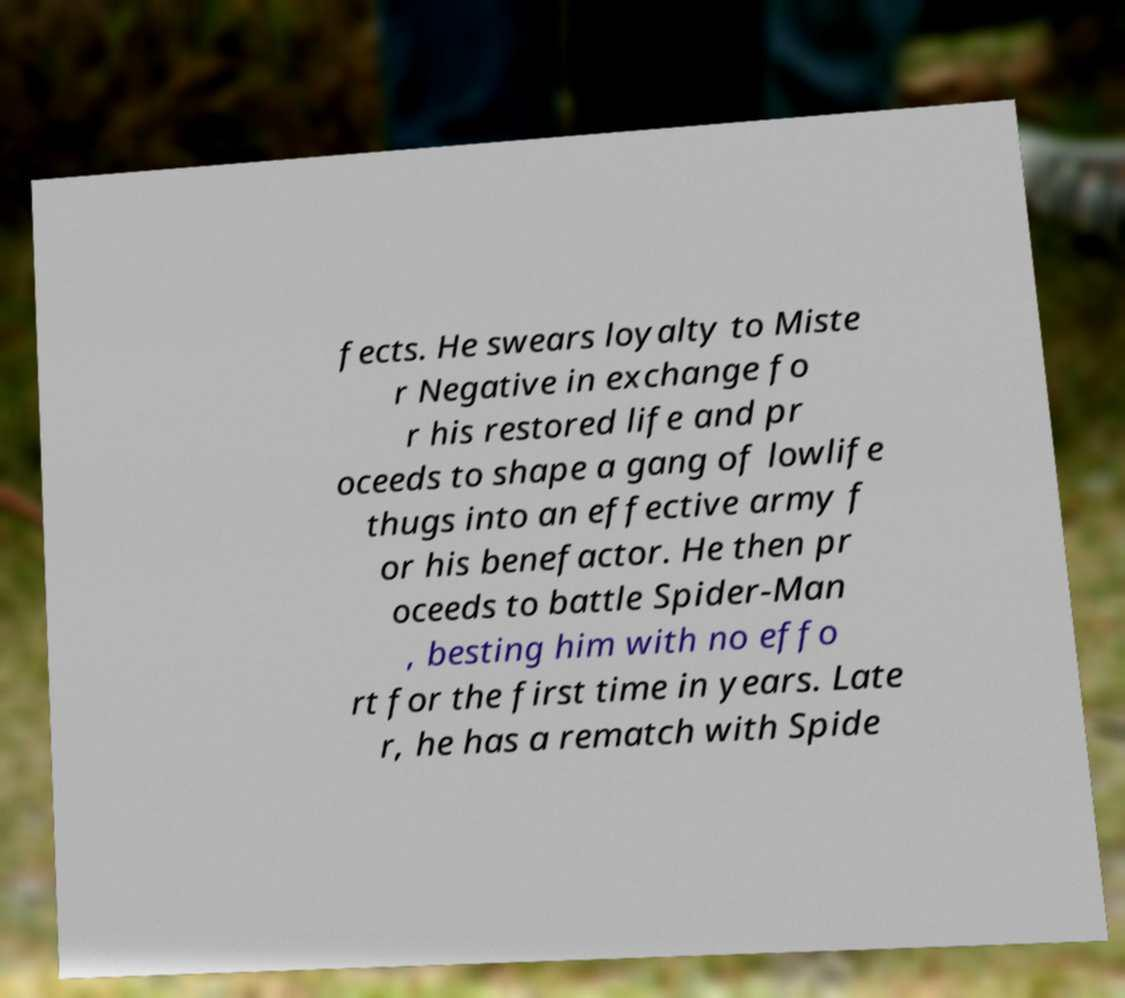Please read and relay the text visible in this image. What does it say? fects. He swears loyalty to Miste r Negative in exchange fo r his restored life and pr oceeds to shape a gang of lowlife thugs into an effective army f or his benefactor. He then pr oceeds to battle Spider-Man , besting him with no effo rt for the first time in years. Late r, he has a rematch with Spide 